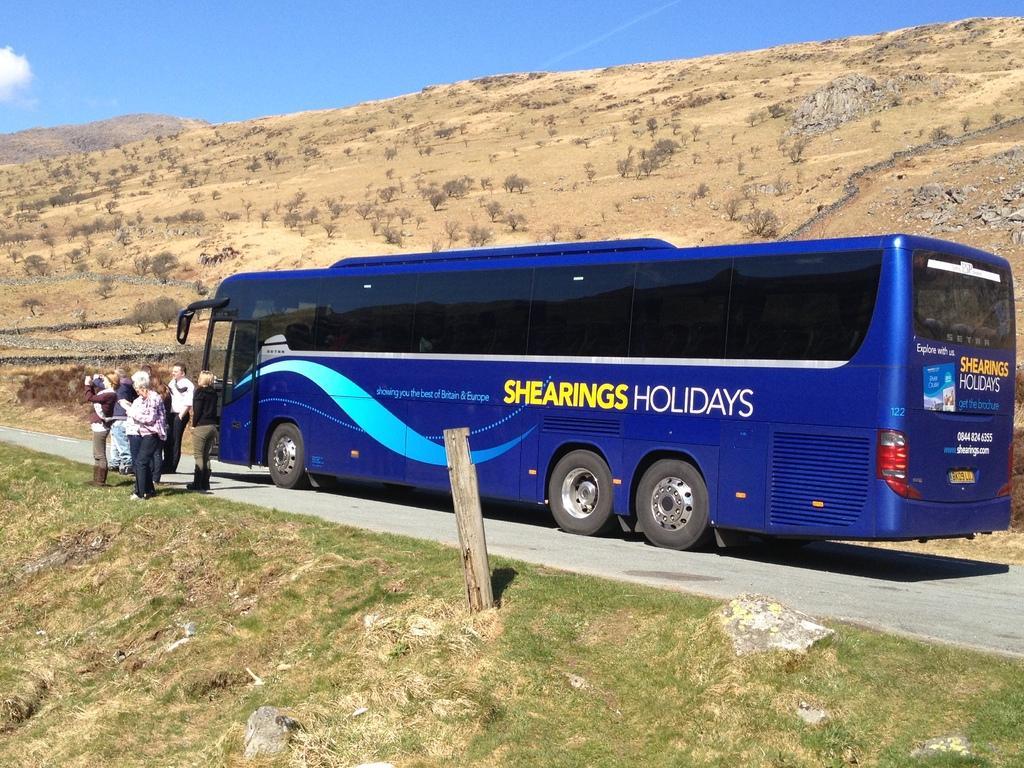How would you summarize this image in a sentence or two? In this image I can see a blue color bus on the road. Here I can see people are standing. Here I can see a wooden pole and the grass. In the background I can see trees, hill and the sky. 